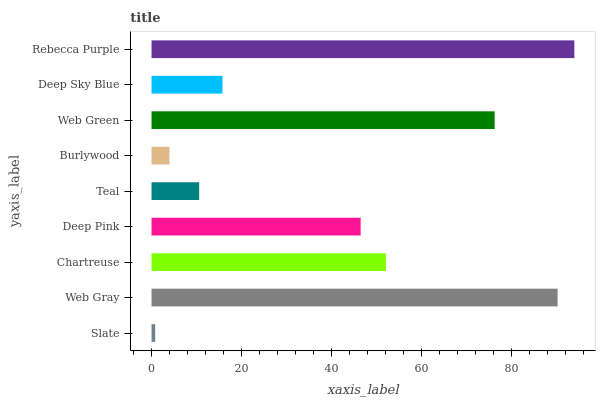Is Slate the minimum?
Answer yes or no. Yes. Is Rebecca Purple the maximum?
Answer yes or no. Yes. Is Web Gray the minimum?
Answer yes or no. No. Is Web Gray the maximum?
Answer yes or no. No. Is Web Gray greater than Slate?
Answer yes or no. Yes. Is Slate less than Web Gray?
Answer yes or no. Yes. Is Slate greater than Web Gray?
Answer yes or no. No. Is Web Gray less than Slate?
Answer yes or no. No. Is Deep Pink the high median?
Answer yes or no. Yes. Is Deep Pink the low median?
Answer yes or no. Yes. Is Slate the high median?
Answer yes or no. No. Is Burlywood the low median?
Answer yes or no. No. 